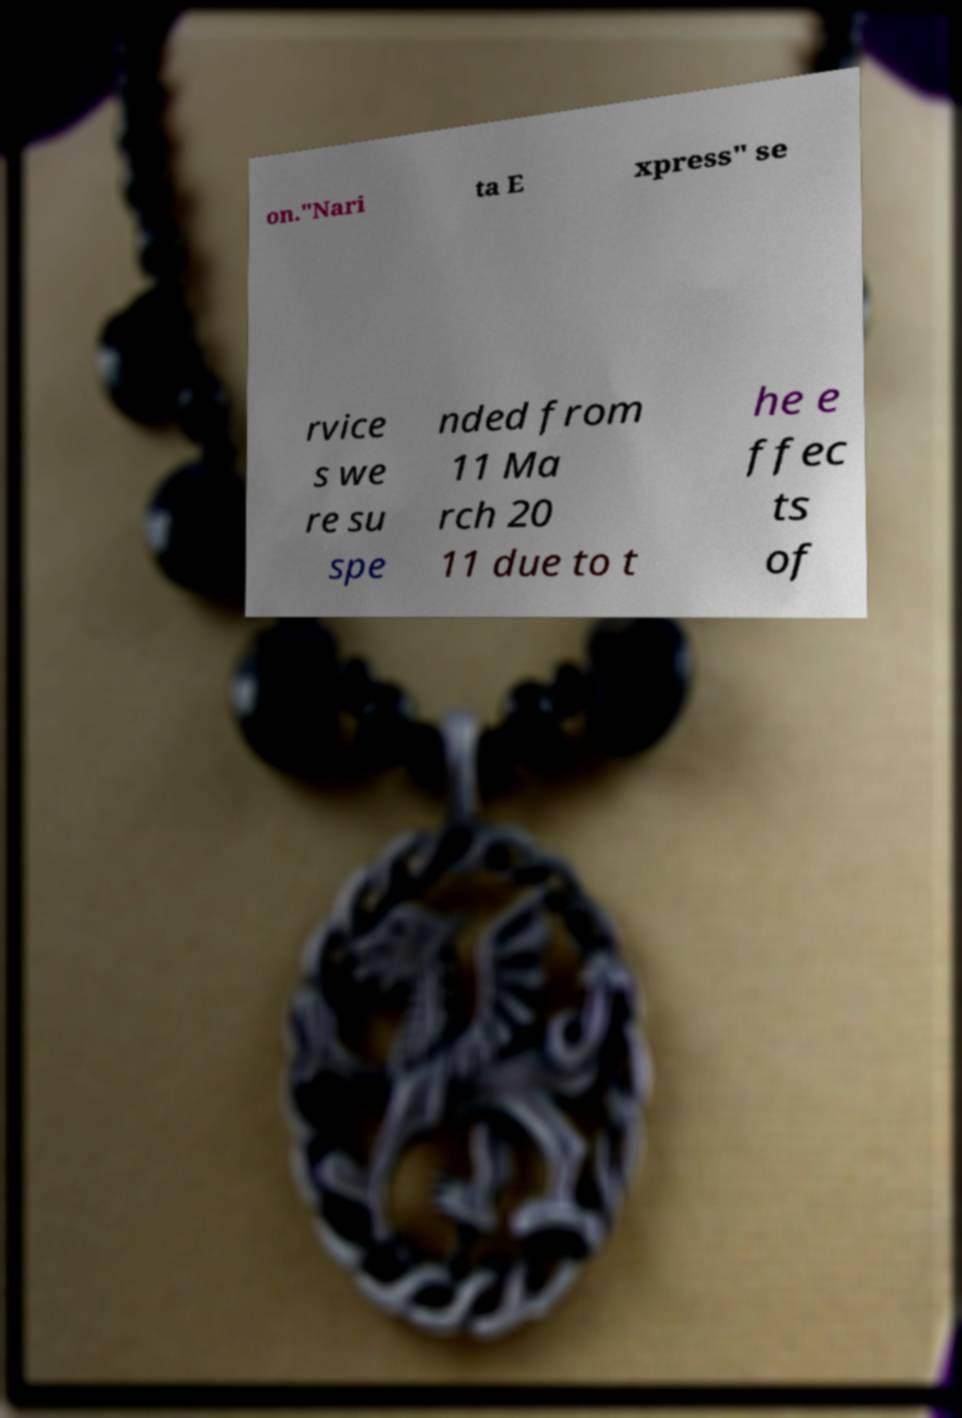Could you extract and type out the text from this image? on."Nari ta E xpress" se rvice s we re su spe nded from 11 Ma rch 20 11 due to t he e ffec ts of 